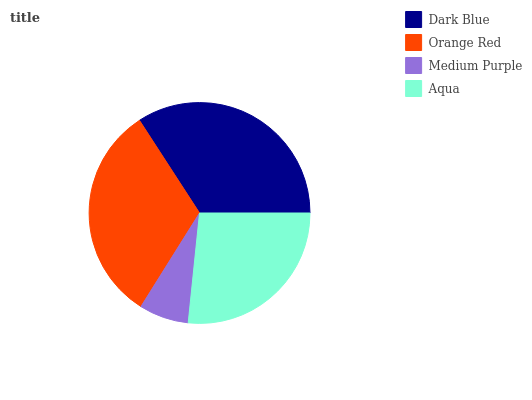Is Medium Purple the minimum?
Answer yes or no. Yes. Is Dark Blue the maximum?
Answer yes or no. Yes. Is Orange Red the minimum?
Answer yes or no. No. Is Orange Red the maximum?
Answer yes or no. No. Is Dark Blue greater than Orange Red?
Answer yes or no. Yes. Is Orange Red less than Dark Blue?
Answer yes or no. Yes. Is Orange Red greater than Dark Blue?
Answer yes or no. No. Is Dark Blue less than Orange Red?
Answer yes or no. No. Is Orange Red the high median?
Answer yes or no. Yes. Is Aqua the low median?
Answer yes or no. Yes. Is Dark Blue the high median?
Answer yes or no. No. Is Orange Red the low median?
Answer yes or no. No. 